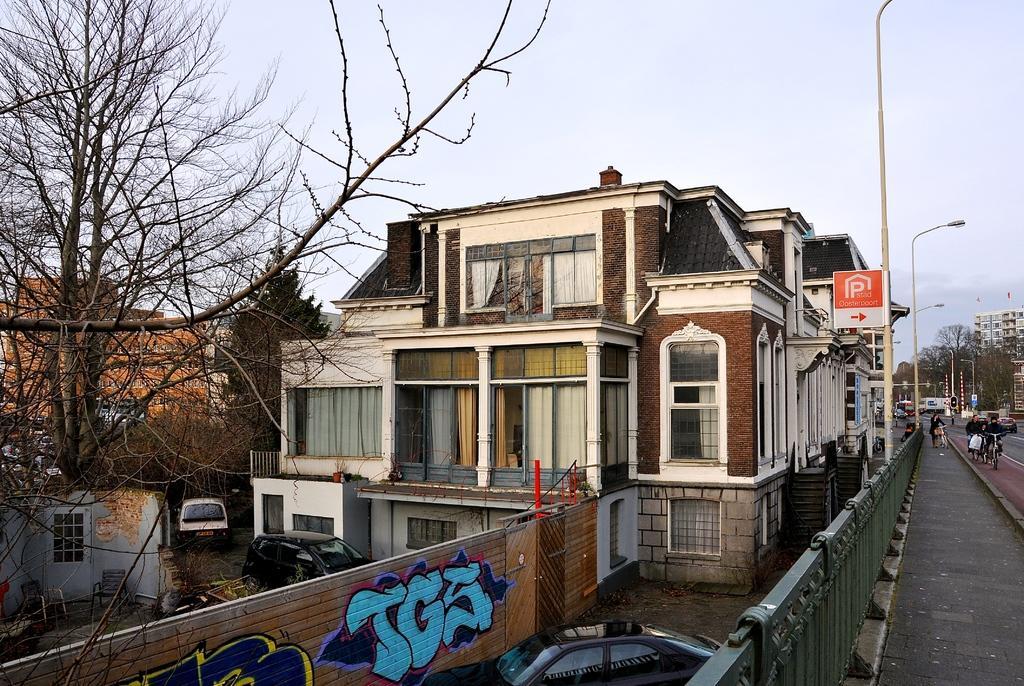Can you describe this image briefly? This is an outside view. On the right side there is a road. Few people are riding the bicycles and there are some other vehicles. Beside the road there is a railing. At the bottom there is a car on the ground. On the left side there is a tree. In the middle of the image I can see the buildings. At the top of the image I can see the sky. Beside the road there are some poles. 